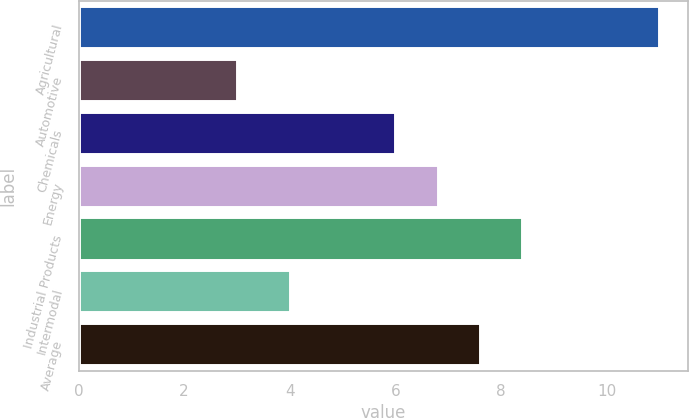<chart> <loc_0><loc_0><loc_500><loc_500><bar_chart><fcel>Agricultural<fcel>Automotive<fcel>Chemicals<fcel>Energy<fcel>Industrial Products<fcel>Intermodal<fcel>Average<nl><fcel>11<fcel>3<fcel>6<fcel>6.8<fcel>8.4<fcel>4<fcel>7.6<nl></chart> 